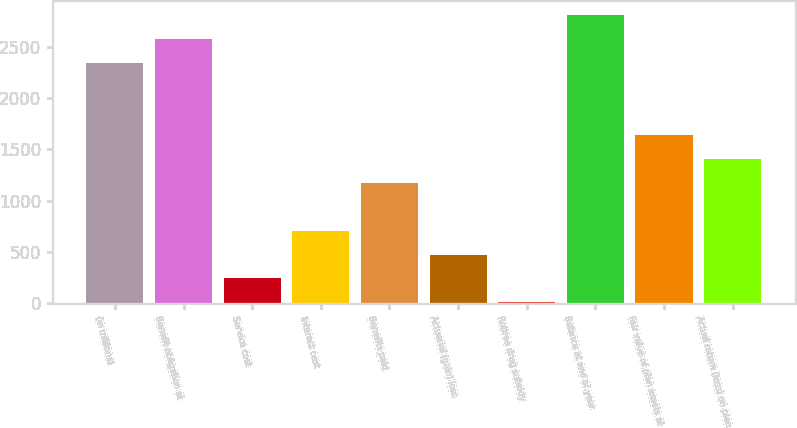<chart> <loc_0><loc_0><loc_500><loc_500><bar_chart><fcel>(in millions)<fcel>Benefit obligation at<fcel>Service cost<fcel>Interest cost<fcel>Benefits paid<fcel>Actuarial (gain) loss<fcel>Retiree drug subsidy<fcel>Balance at end of year<fcel>Fair value of plan assets at<fcel>Actual return (loss) on plan<nl><fcel>2339<fcel>2572.2<fcel>240.2<fcel>706.6<fcel>1173<fcel>473.4<fcel>7<fcel>2805.4<fcel>1639.4<fcel>1406.2<nl></chart> 